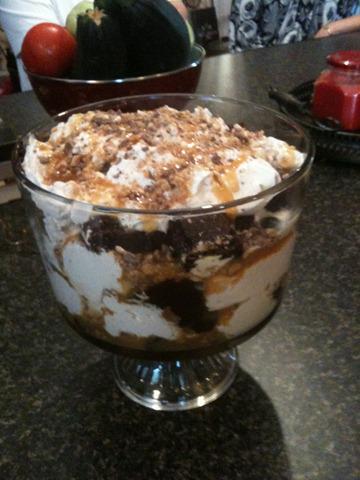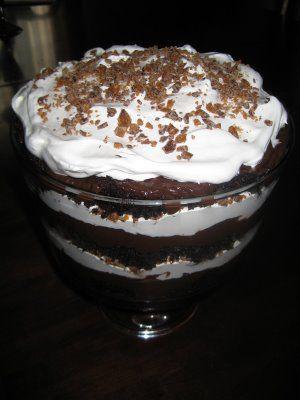The first image is the image on the left, the second image is the image on the right. Examine the images to the left and right. Is the description "One image shows a large dessert in a clear glass footed bowl, while the second image shows three individual layered desserts in glasses." accurate? Answer yes or no. No. The first image is the image on the left, the second image is the image on the right. Analyze the images presented: Is the assertion "There are three cups of dessert in the image on the left." valid? Answer yes or no. No. 